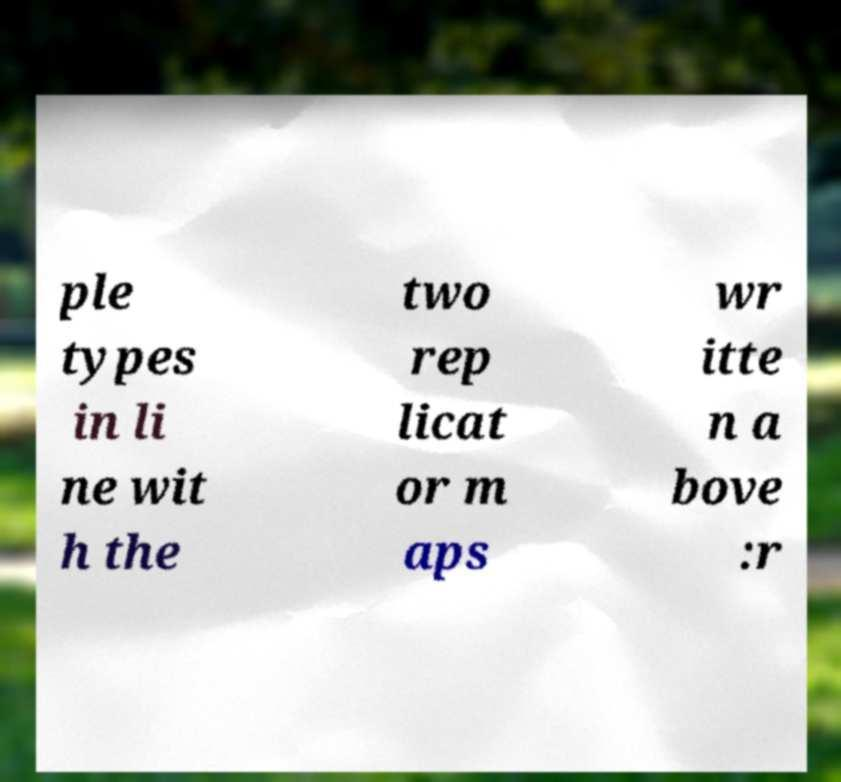There's text embedded in this image that I need extracted. Can you transcribe it verbatim? ple types in li ne wit h the two rep licat or m aps wr itte n a bove :r 